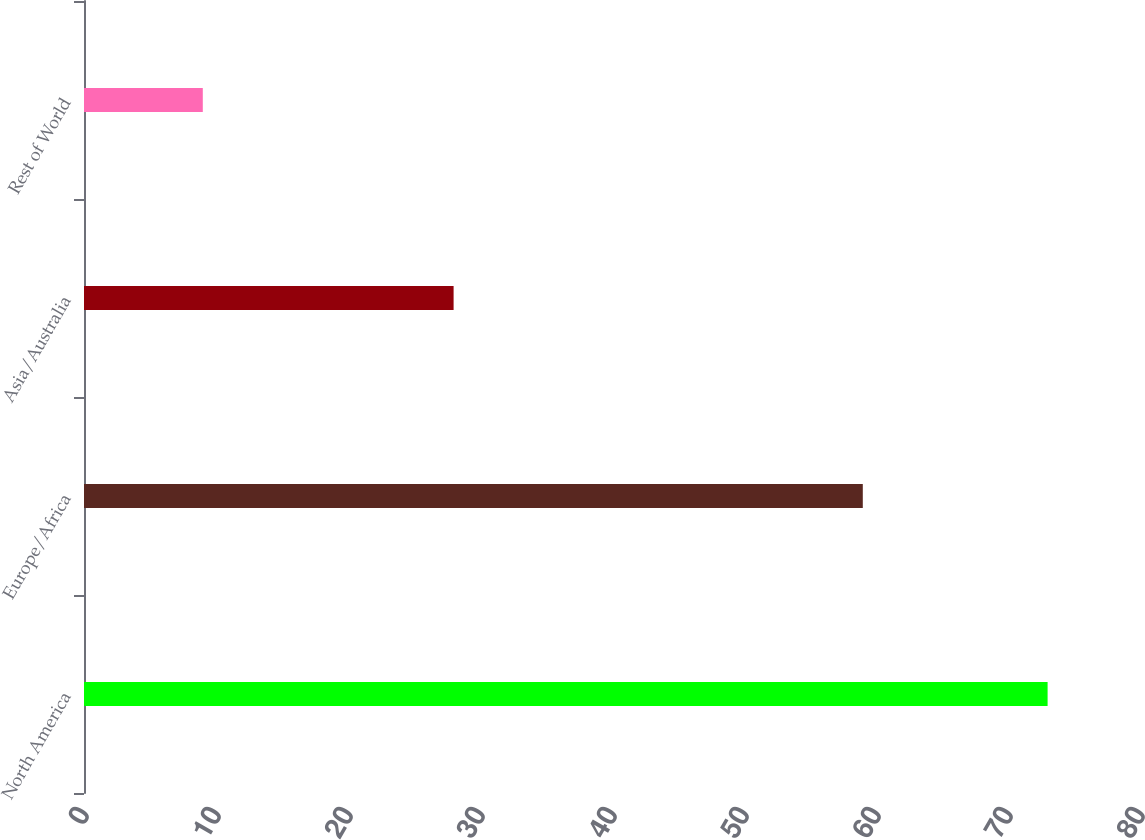<chart> <loc_0><loc_0><loc_500><loc_500><bar_chart><fcel>North America<fcel>Europe/Africa<fcel>Asia/Australia<fcel>Rest of World<nl><fcel>73<fcel>59<fcel>28<fcel>9<nl></chart> 